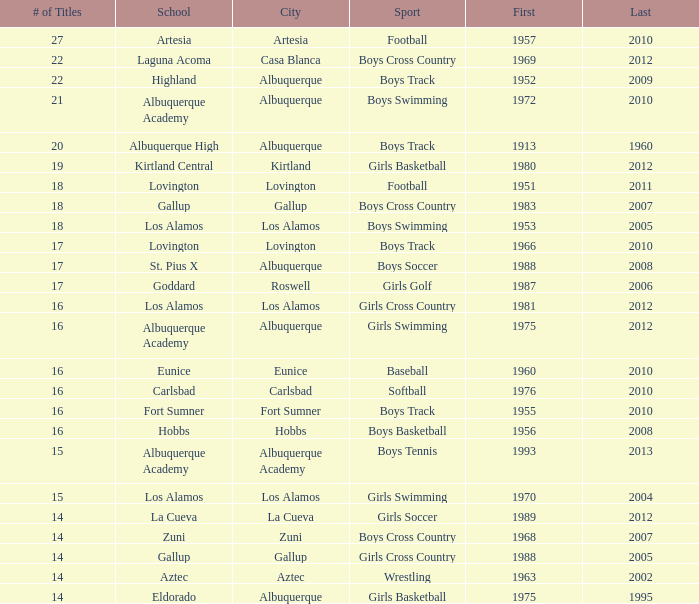In which city is the school, highland, located that holds a rank under 8 and won its initial title before 1980 and the latest one post 1960? Albuquerque. Can you give me this table as a dict? {'header': ['# of Titles', 'School', 'City', 'Sport', 'First', 'Last'], 'rows': [['27', 'Artesia', 'Artesia', 'Football', '1957', '2010'], ['22', 'Laguna Acoma', 'Casa Blanca', 'Boys Cross Country', '1969', '2012'], ['22', 'Highland', 'Albuquerque', 'Boys Track', '1952', '2009'], ['21', 'Albuquerque Academy', 'Albuquerque', 'Boys Swimming', '1972', '2010'], ['20', 'Albuquerque High', 'Albuquerque', 'Boys Track', '1913', '1960'], ['19', 'Kirtland Central', 'Kirtland', 'Girls Basketball', '1980', '2012'], ['18', 'Lovington', 'Lovington', 'Football', '1951', '2011'], ['18', 'Gallup', 'Gallup', 'Boys Cross Country', '1983', '2007'], ['18', 'Los Alamos', 'Los Alamos', 'Boys Swimming', '1953', '2005'], ['17', 'Lovington', 'Lovington', 'Boys Track', '1966', '2010'], ['17', 'St. Pius X', 'Albuquerque', 'Boys Soccer', '1988', '2008'], ['17', 'Goddard', 'Roswell', 'Girls Golf', '1987', '2006'], ['16', 'Los Alamos', 'Los Alamos', 'Girls Cross Country', '1981', '2012'], ['16', 'Albuquerque Academy', 'Albuquerque', 'Girls Swimming', '1975', '2012'], ['16', 'Eunice', 'Eunice', 'Baseball', '1960', '2010'], ['16', 'Carlsbad', 'Carlsbad', 'Softball', '1976', '2010'], ['16', 'Fort Sumner', 'Fort Sumner', 'Boys Track', '1955', '2010'], ['16', 'Hobbs', 'Hobbs', 'Boys Basketball', '1956', '2008'], ['15', 'Albuquerque Academy', 'Albuquerque Academy', 'Boys Tennis', '1993', '2013'], ['15', 'Los Alamos', 'Los Alamos', 'Girls Swimming', '1970', '2004'], ['14', 'La Cueva', 'La Cueva', 'Girls Soccer', '1989', '2012'], ['14', 'Zuni', 'Zuni', 'Boys Cross Country', '1968', '2007'], ['14', 'Gallup', 'Gallup', 'Girls Cross Country', '1988', '2005'], ['14', 'Aztec', 'Aztec', 'Wrestling', '1963', '2002'], ['14', 'Eldorado', 'Albuquerque', 'Girls Basketball', '1975', '1995']]} 